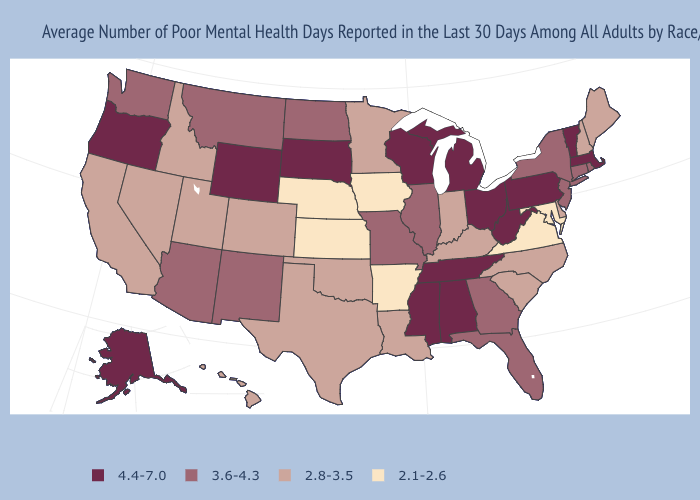Does the map have missing data?
Keep it brief. No. Name the states that have a value in the range 4.4-7.0?
Concise answer only. Alabama, Alaska, Massachusetts, Michigan, Mississippi, Ohio, Oregon, Pennsylvania, South Dakota, Tennessee, Vermont, West Virginia, Wisconsin, Wyoming. Among the states that border North Dakota , which have the lowest value?
Keep it brief. Minnesota. What is the highest value in the USA?
Give a very brief answer. 4.4-7.0. Name the states that have a value in the range 4.4-7.0?
Quick response, please. Alabama, Alaska, Massachusetts, Michigan, Mississippi, Ohio, Oregon, Pennsylvania, South Dakota, Tennessee, Vermont, West Virginia, Wisconsin, Wyoming. Does Nebraska have the lowest value in the USA?
Give a very brief answer. Yes. Name the states that have a value in the range 2.1-2.6?
Concise answer only. Arkansas, Iowa, Kansas, Maryland, Nebraska, Virginia. Is the legend a continuous bar?
Quick response, please. No. Is the legend a continuous bar?
Keep it brief. No. Which states hav the highest value in the West?
Give a very brief answer. Alaska, Oregon, Wyoming. What is the highest value in the USA?
Give a very brief answer. 4.4-7.0. What is the value of Mississippi?
Be succinct. 4.4-7.0. Name the states that have a value in the range 4.4-7.0?
Keep it brief. Alabama, Alaska, Massachusetts, Michigan, Mississippi, Ohio, Oregon, Pennsylvania, South Dakota, Tennessee, Vermont, West Virginia, Wisconsin, Wyoming. Name the states that have a value in the range 4.4-7.0?
Short answer required. Alabama, Alaska, Massachusetts, Michigan, Mississippi, Ohio, Oregon, Pennsylvania, South Dakota, Tennessee, Vermont, West Virginia, Wisconsin, Wyoming. What is the value of South Dakota?
Answer briefly. 4.4-7.0. 